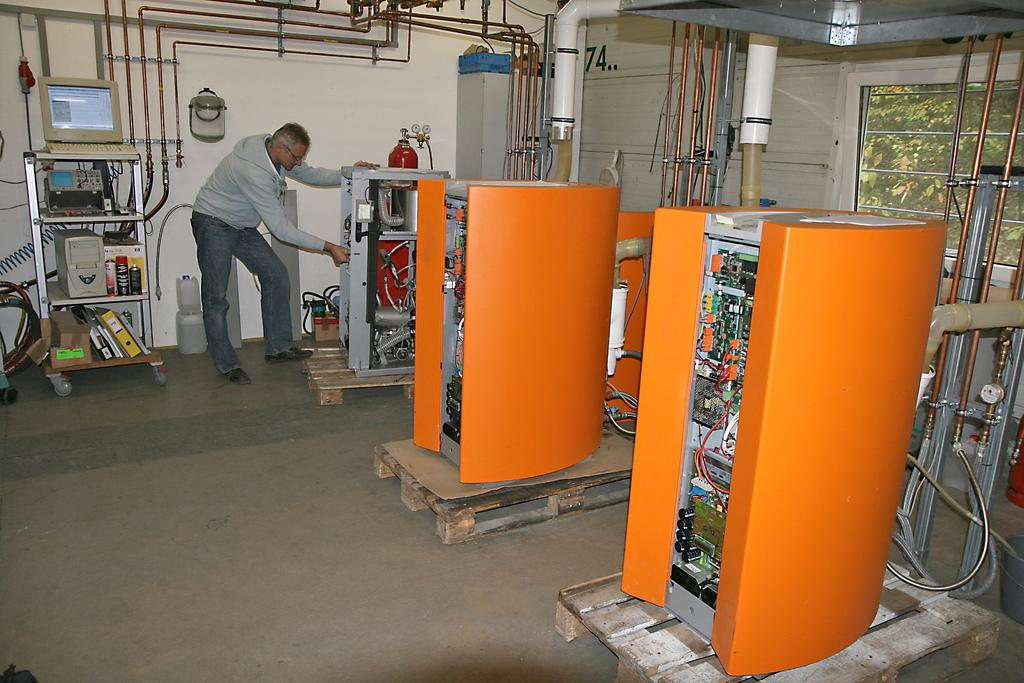<image>
Render a clear and concise summary of the photo. a man in a room with a computer behind him that has Windows open and an X in the corner 